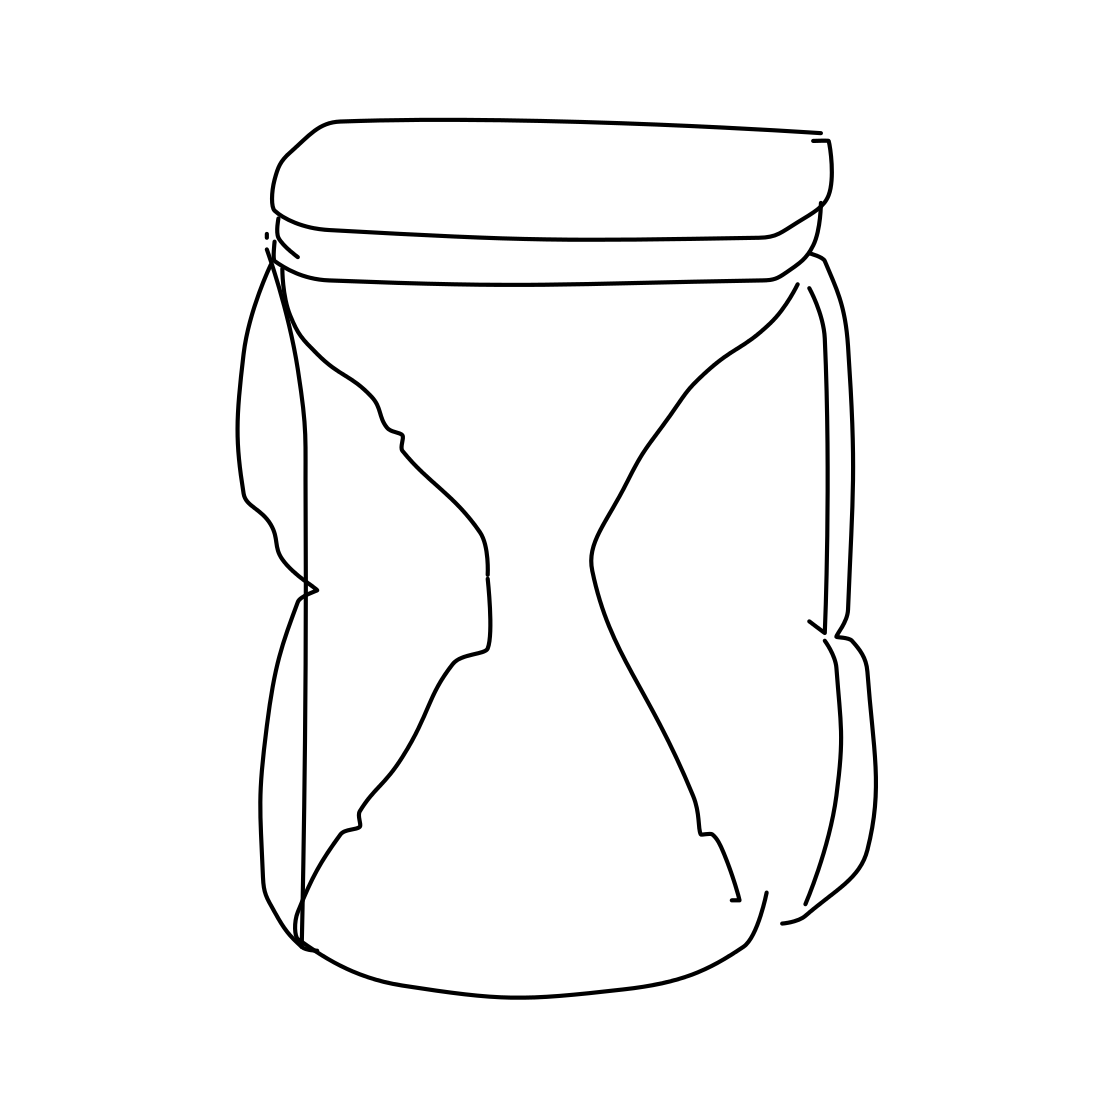Is there a sketchy telephone in the picture? No, there is no sketchy telephone in the picture. The image actually depicts a simple line drawing of an empty jar with a noticeable distortion making it appear as if it's squeezed in the middle. 